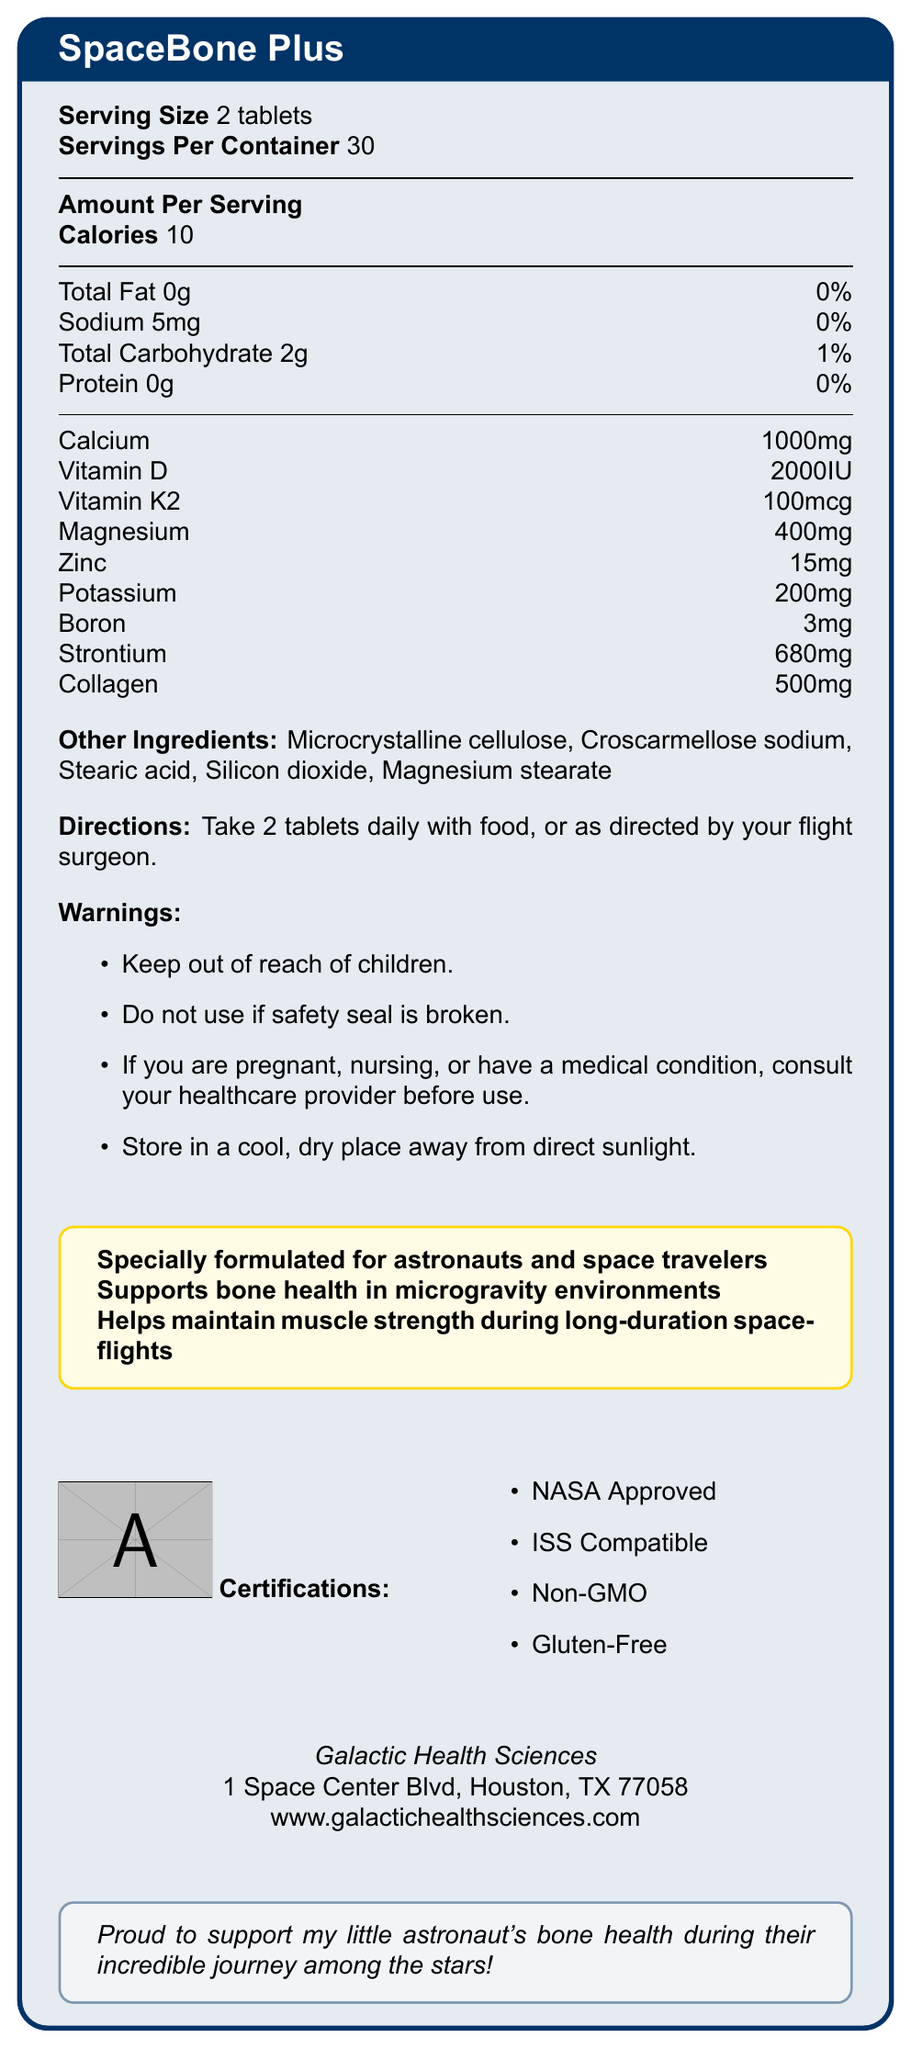what is the product name? The product name "SpaceBone Plus" is prominently displayed in the document's title.
Answer: SpaceBone Plus how many tablets are in each serving? The serving size is listed as "2 tablets."
Answer: 2 tablets how many servings are there per container? The Nutrition Facts label states there are 30 servings per container.
Answer: 30 what is the calorie count per serving? The amount per serving is specified as "Calories 10."
Answer: 10 what ingredient supports bone health in zero gravity? The document details various components that support bone health, especially emphasizing calcium, vitamin D, and vitamin K2.
Answer: Multiple ingredients such as calcium, vitamin D, and vitamin K2 What is the sodium content per serving? The document lists sodium content as 5 mg per serving.
Answer: 5 mg what are the certifications of the product? A. USDA Organic, Non-GMO B. NSF Certified, Vegan C. NASA Approved, Non-GMO The product is certified as "NASA Approved," "ISS Compatible," "Non-GMO," and "Gluten-Free."
Answer: C how much calcium is in one serving? A. 500 mg B. 1000 mg C. 1500 mg D. 2000 mg Each serving contains 1000 mg of calcium.
Answer: B is the product gluten-free? The certifications section states that the product is "Gluten-Free."
Answer: Yes what is the address of the manufacturer? The manufacturer's address is clearly listed as "1 Space Center Blvd, Houston, TX 77058."
Answer: 1 Space Center Blvd, Houston, TX 77058 what is the recommended dosage? The directions suggest taking "2 tablets daily with food, or as directed by your flight surgeon."
Answer: 2 tablets daily with food, or as directed by your flight surgeon. what should one do if the safety seal is broken? The warnings section advises not to use the product if the safety seal is broken.
Answer: Do not use the product. who should you consult before using this product if you have a medical condition? The warnings section advises consulting your healthcare provider if you have a medical condition.
Answer: Your healthcare provider what are some of the minor ingredients listed? The other ingredients section lists these minor ingredients.
Answer: Microcrystalline cellulose, Croscarmellose sodium, Stearic acid, Silicon dioxide, Magnesium stearate summarize the main idea of this document. The document primarily focuses on detailing the contents, purpose, and safe usage of the vitamin supplement SpaceBone Plus.
Answer: The document provides the nutritional facts, ingredients, dosage instructions, warnings, and certifications for SpaceBone Plus, a vitamin supplement designed to support bone health in space environments. what time of year should this product be stored? The document advises storing in a cool, dry place away from direct sunlight but does not specify any time of year.
Answer: Not enough information 